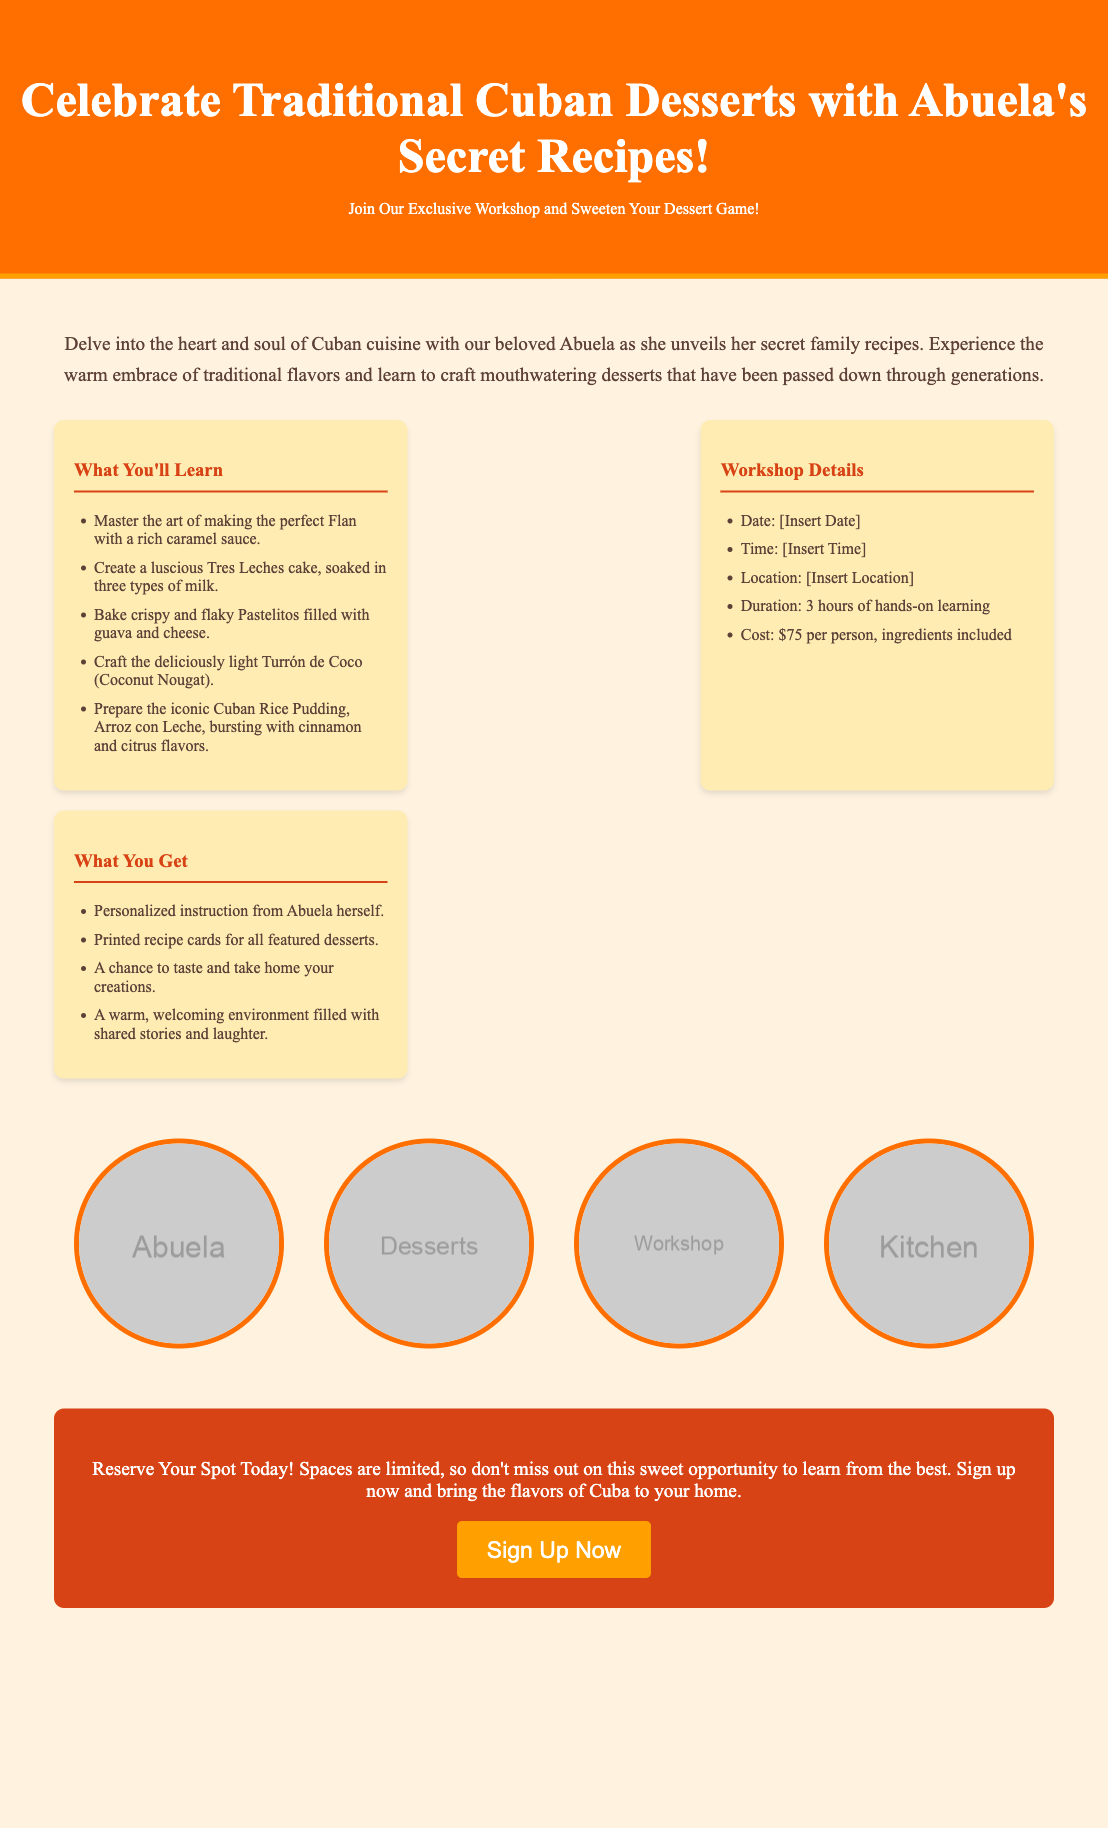What is the workshop cost? The workshop cost is mentioned in the section detailing workshop information as $75 per person.
Answer: $75 What desserts will be learned? The document lists specific desserts that will be taught during the workshop, including Flan, Tres Leches, and Pastelitos.
Answer: Flan, Tres Leches, Pastelitos How long is the workshop? The duration of the workshop is specified in the details section as 3 hours of hands-on learning.
Answer: 3 hours What date is the workshop? The document mentions a placeholder for the date of the workshop, indicating that it is to be inserted.
Answer: [Insert Date] Who is the instructor? The advertisement highlights that the workshop will have personalized instruction from Abuela.
Answer: Abuela What type of environment is the workshop held in? The document describes the workshop environment as warm and welcoming, filled with shared stories and laughter.
Answer: Warm and welcoming What can participants take home? The document states that participants will have a chance to taste and take home their creations made during the workshop.
Answer: Their creations How many types of milk are used in Tres Leches? The name "Tres Leches" indicates that three types of milk are used in the cake recipe, which is mentioned in the details.
Answer: Three types 